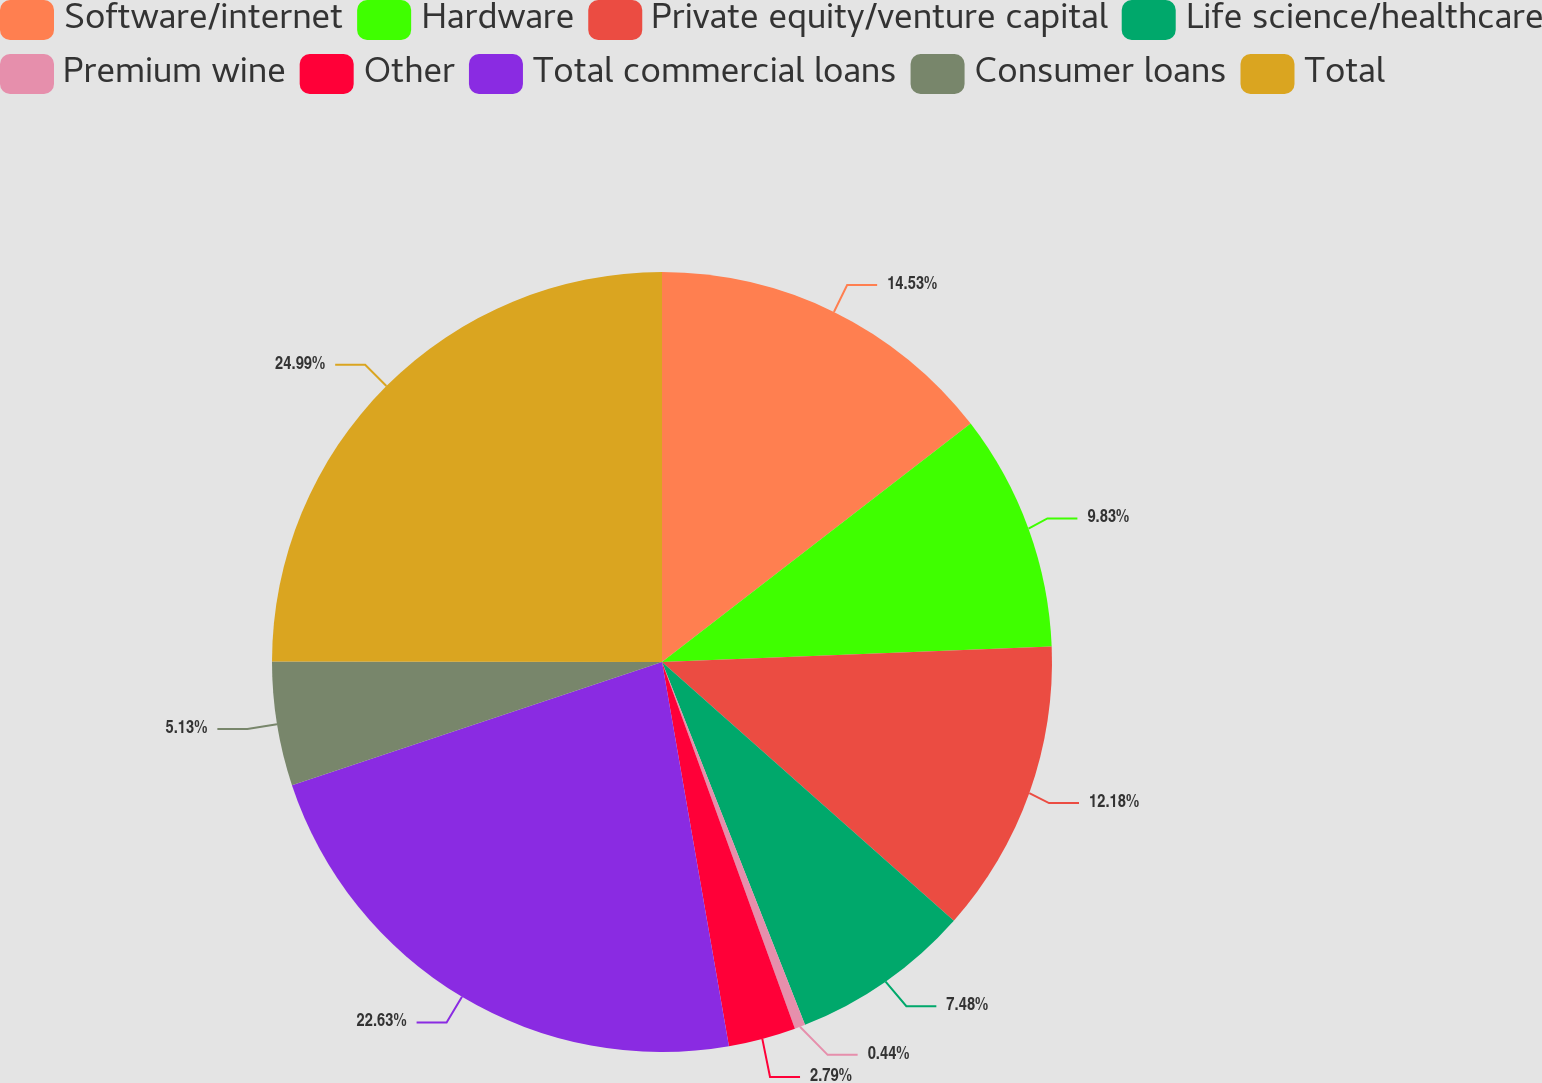Convert chart. <chart><loc_0><loc_0><loc_500><loc_500><pie_chart><fcel>Software/internet<fcel>Hardware<fcel>Private equity/venture capital<fcel>Life science/healthcare<fcel>Premium wine<fcel>Other<fcel>Total commercial loans<fcel>Consumer loans<fcel>Total<nl><fcel>14.53%<fcel>9.83%<fcel>12.18%<fcel>7.48%<fcel>0.44%<fcel>2.79%<fcel>22.63%<fcel>5.13%<fcel>24.98%<nl></chart> 